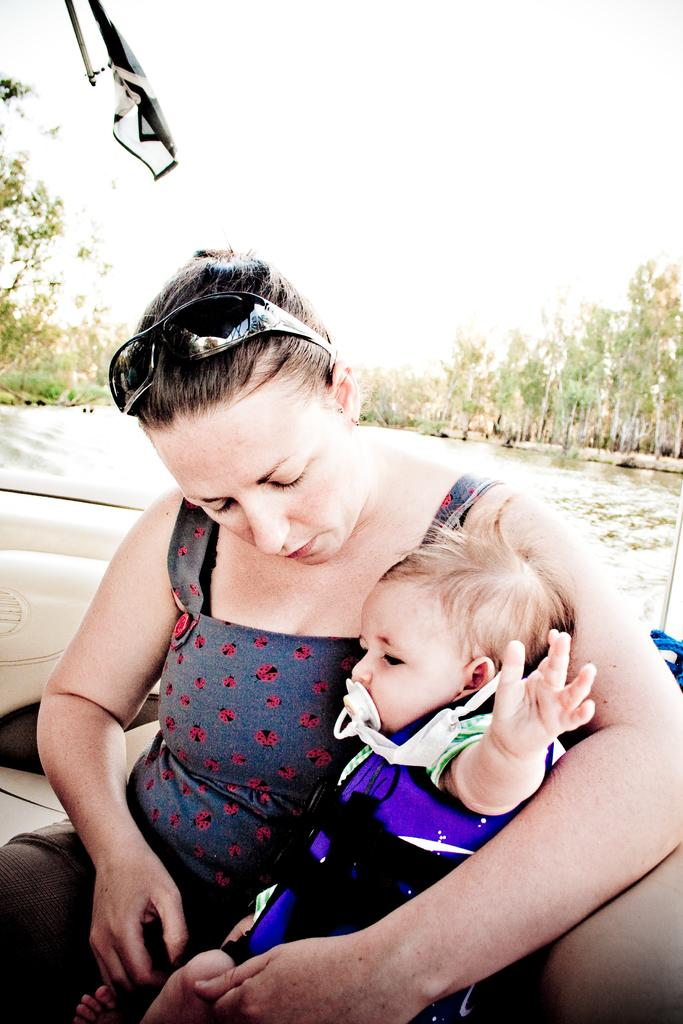Who is the main subject in the image? There is a woman in the image. What is the woman doing in the image? The woman is sitting in the front and holding a small baby in her hand. What can be seen in the background of the image? There are trees visible in the background of the image. What type of meeting is taking place in the image? There is no meeting present in the image; it features a woman sitting and holding a small baby. What religious belief is being practiced in the image? There is no indication of any religious belief being practiced in the image. 